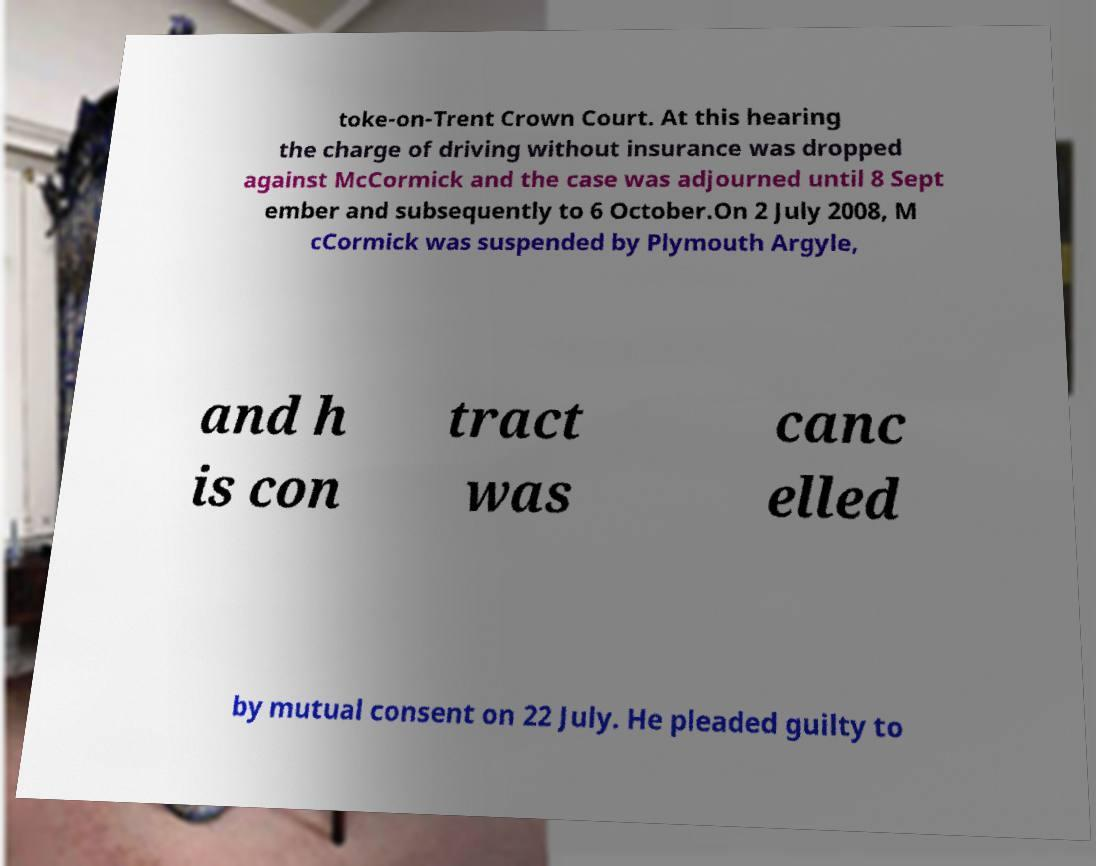Can you read and provide the text displayed in the image?This photo seems to have some interesting text. Can you extract and type it out for me? toke-on-Trent Crown Court. At this hearing the charge of driving without insurance was dropped against McCormick and the case was adjourned until 8 Sept ember and subsequently to 6 October.On 2 July 2008, M cCormick was suspended by Plymouth Argyle, and h is con tract was canc elled by mutual consent on 22 July. He pleaded guilty to 